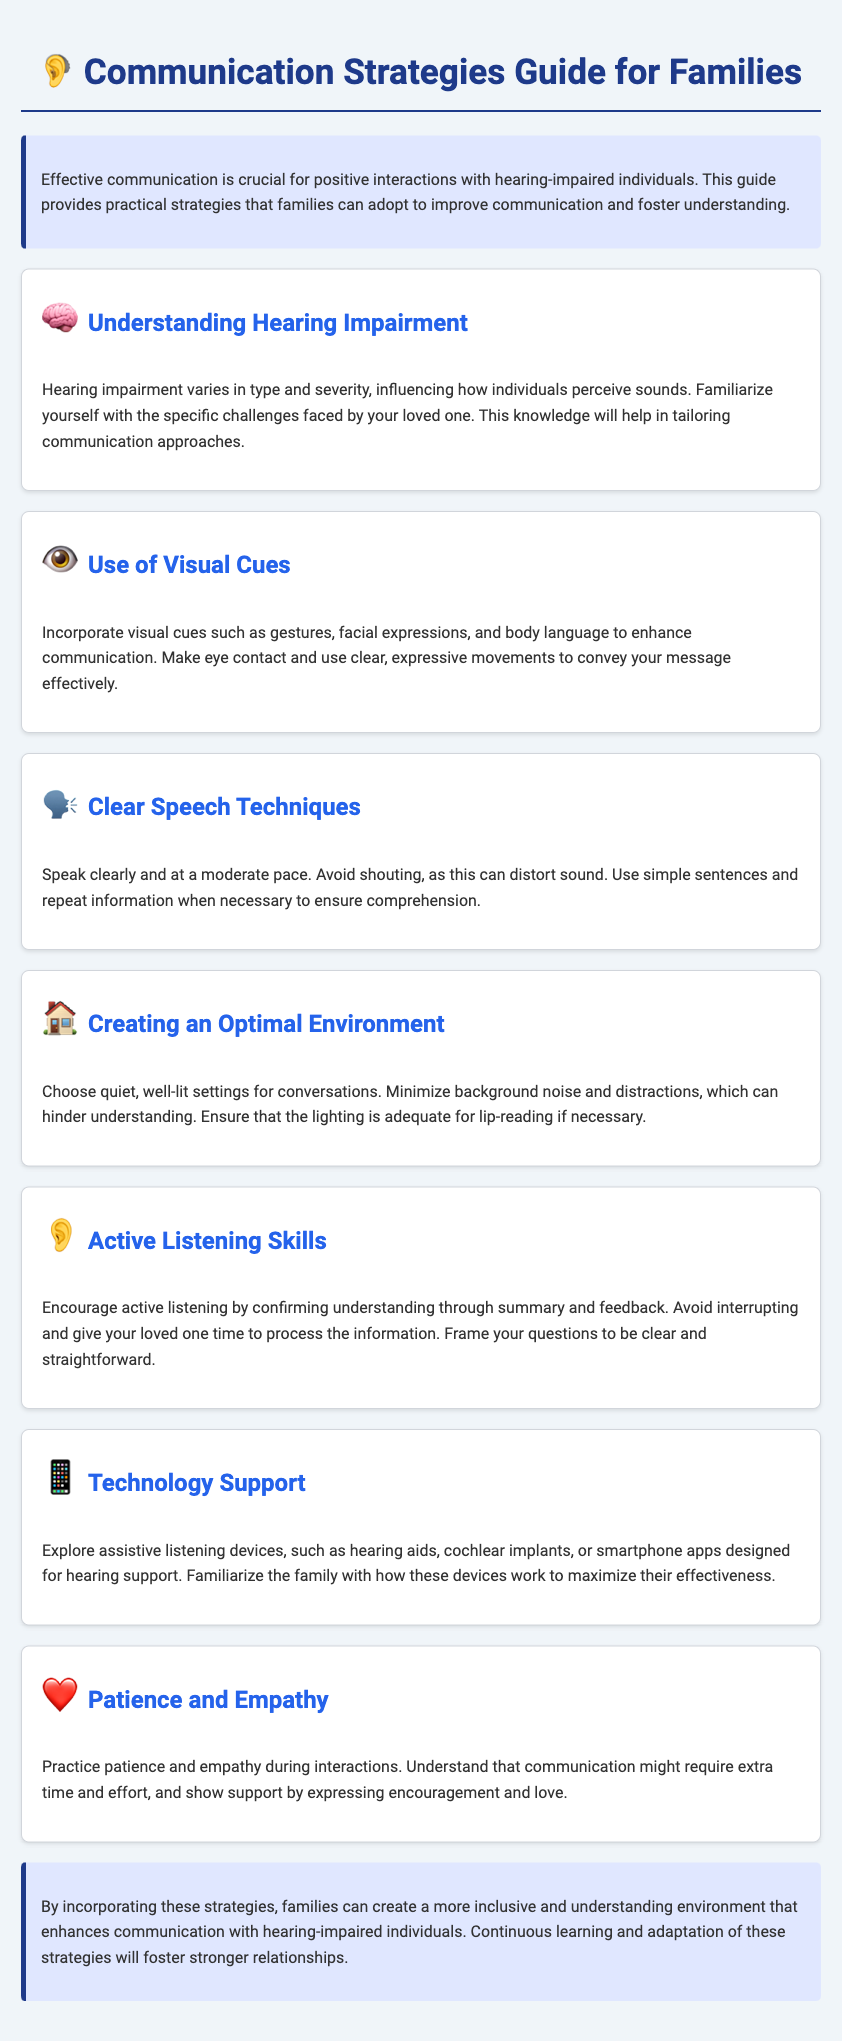what is the title of the document? The title of the document is presented prominently at the top.
Answer: Communication Strategies Guide for Families what section discusses visual cues? The section that discusses visual cues is titled within the document clearly.
Answer: Use of Visual Cues how many sections are there in the document? The document consists of several sections under different headings.
Answer: 7 what is the icon used for understanding hearing impairment? The icon used for the section about understanding hearing impairment is described visually.
Answer: 🧠 what communication technique is recommended for speech? The document lists specific techniques for effective speech communication.
Answer: Clear Speech Techniques what should be minimized to enhance conversation understanding? The document specifies environmental factors that can hinder effective communication.
Answer: Background noise what is suggested to create an optimal environment for conversations? The section outlines specific conditions for conducive communication spaces.
Answer: Quiet, well-lit settings what do families need to familiarize themselves with in terms of technology? The document encourages families to learn about specific types of technology for support.
Answer: Assistive listening devices 